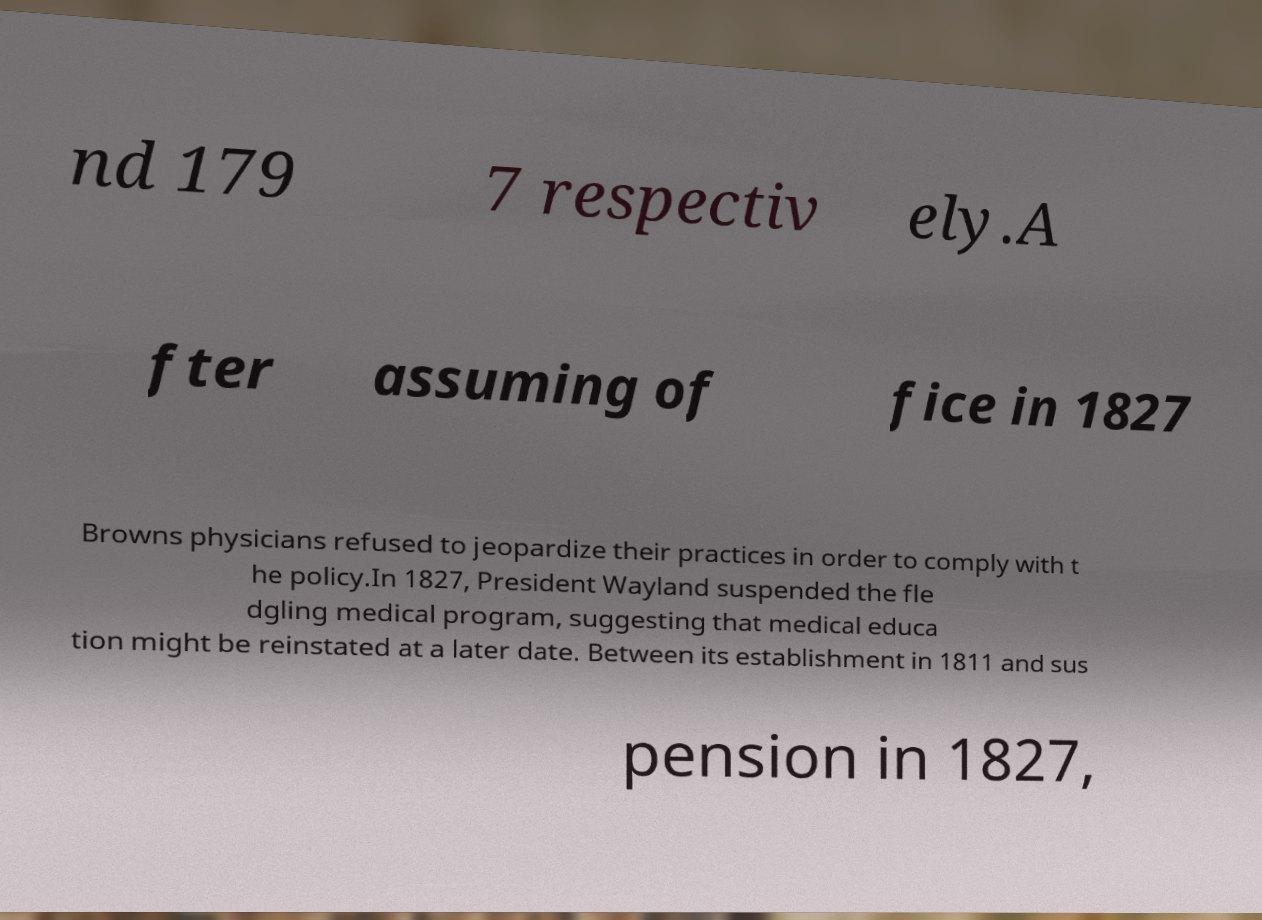Could you extract and type out the text from this image? nd 179 7 respectiv ely.A fter assuming of fice in 1827 Browns physicians refused to jeopardize their practices in order to comply with t he policy.In 1827, President Wayland suspended the fle dgling medical program, suggesting that medical educa tion might be reinstated at a later date. Between its establishment in 1811 and sus pension in 1827, 